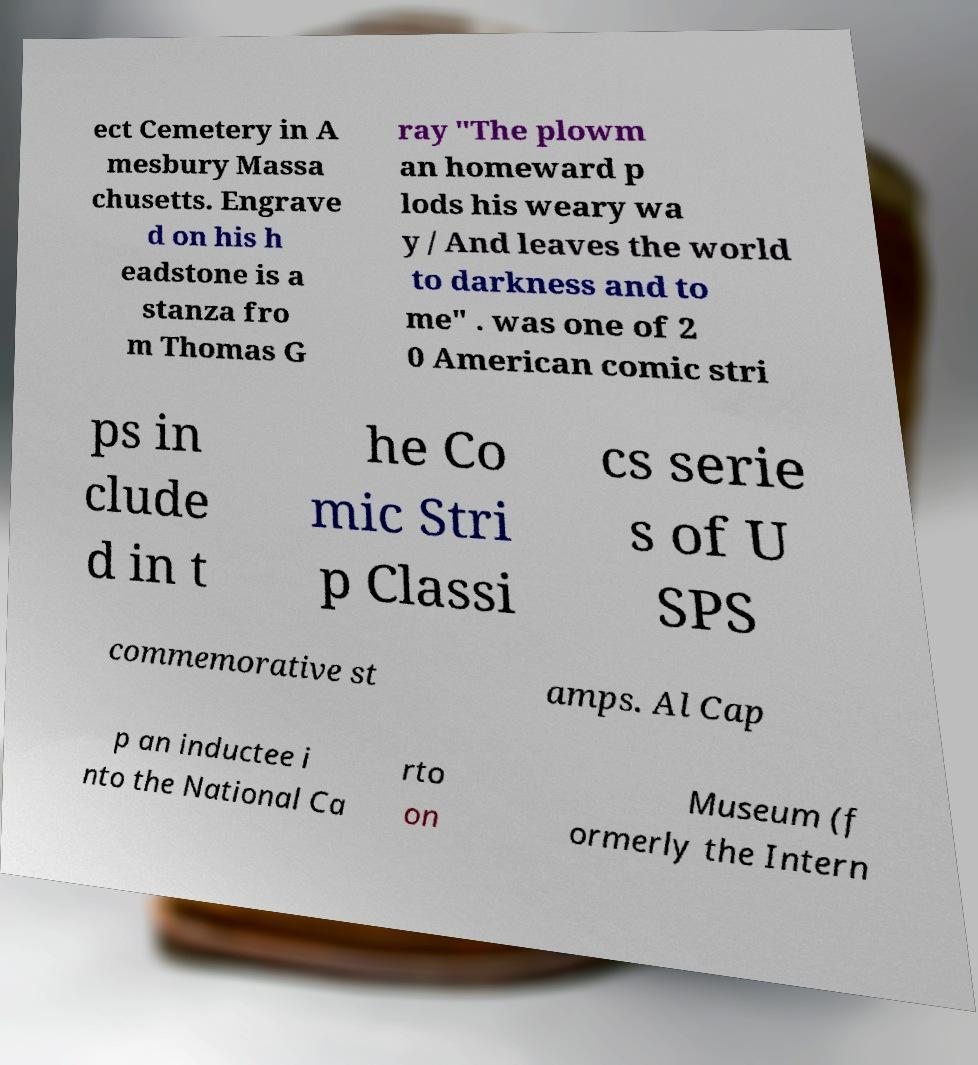Can you accurately transcribe the text from the provided image for me? ect Cemetery in A mesbury Massa chusetts. Engrave d on his h eadstone is a stanza fro m Thomas G ray "The plowm an homeward p lods his weary wa y / And leaves the world to darkness and to me" . was one of 2 0 American comic stri ps in clude d in t he Co mic Stri p Classi cs serie s of U SPS commemorative st amps. Al Cap p an inductee i nto the National Ca rto on Museum (f ormerly the Intern 